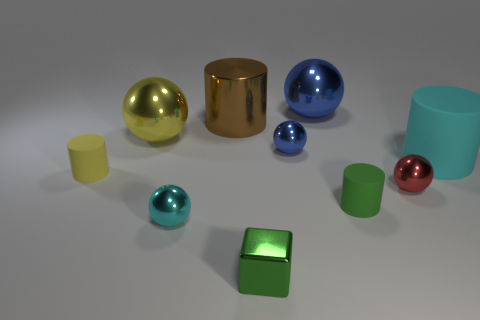What number of cubes are either big cyan objects or tiny red metallic objects?
Offer a very short reply. 0. How many objects are big shiny cylinders or big spheres in front of the large blue metal sphere?
Give a very brief answer. 2. Are any purple spheres visible?
Provide a succinct answer. No. How many big matte cylinders have the same color as the small shiny cube?
Offer a terse response. 0. What material is the tiny object that is the same color as the large rubber cylinder?
Provide a succinct answer. Metal. What is the size of the blue shiny thing on the left side of the large metal sphere on the right side of the cyan ball?
Your response must be concise. Small. Are there any big blue spheres that have the same material as the large brown cylinder?
Ensure brevity in your answer.  Yes. There is a block that is the same size as the red ball; what material is it?
Your answer should be very brief. Metal. There is a small matte cylinder that is left of the cyan metal sphere; does it have the same color as the large ball to the right of the big yellow metallic object?
Provide a short and direct response. No. There is a large sphere that is behind the big yellow metallic thing; is there a shiny ball that is right of it?
Provide a succinct answer. Yes. 